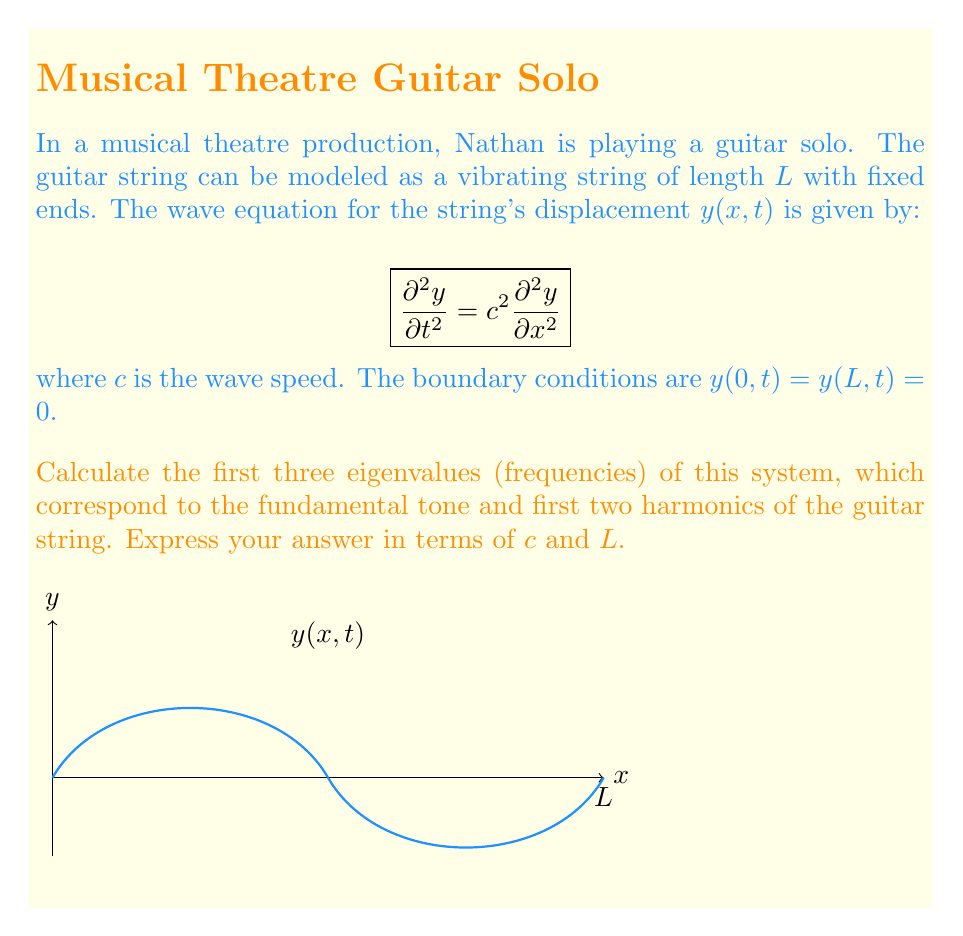Can you answer this question? Let's approach this step-by-step:

1) For a vibrating string with fixed ends, we can use the method of separation of variables. We assume a solution of the form:

   $y(x,t) = X(x)T(t)$

2) Substituting this into the wave equation and separating variables, we get:

   $\frac{1}{c^2} \frac{T''(t)}{T(t)} = \frac{X''(x)}{X(x)} = -\lambda$

   where $\lambda$ is a constant.

3) This leads to two equations:
   
   $X''(x) + \lambda X(x) = 0$
   $T''(t) + \lambda c^2 T(t) = 0$

4) The spatial equation $X''(x) + \lambda X(x) = 0$ with boundary conditions $X(0) = X(L) = 0$ is a Sturm-Liouville problem. Its solutions are:

   $X_n(x) = \sin(\frac{n\pi x}{L})$, where $n = 1, 2, 3, ...$

5) The corresponding eigenvalues are:

   $\lambda_n = (\frac{n\pi}{L})^2$

6) The angular frequencies $\omega_n$ are related to $\lambda_n$ by:

   $\omega_n = c\sqrt{\lambda_n} = \frac{n\pi c}{L}$

7) Therefore, the first three eigenvalues (frequencies) are:

   $\omega_1 = \frac{\pi c}{L}$ (fundamental tone)
   $\omega_2 = \frac{2\pi c}{L}$ (first harmonic)
   $\omega_3 = \frac{3\pi c}{L}$ (second harmonic)

These frequencies correspond to the musical notes that Nathan's guitar string can produce.
Answer: $\omega_1 = \frac{\pi c}{L}$, $\omega_2 = \frac{2\pi c}{L}$, $\omega_3 = \frac{3\pi c}{L}$ 